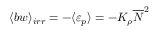Convert formula to latex. <formula><loc_0><loc_0><loc_500><loc_500>\langle b w \rangle _ { i r r } = - \langle \varepsilon _ { p } \rangle = - K _ { \rho } \overline { N } ^ { 2 }</formula> 